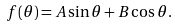Convert formula to latex. <formula><loc_0><loc_0><loc_500><loc_500>f ( \theta ) = A \sin { \theta } + B \cos { \theta } .</formula> 